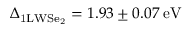<formula> <loc_0><loc_0><loc_500><loc_500>\Delta _ { 1 L W S e _ { 2 } } = 1 . 9 3 \pm 0 . 0 7 \, e V</formula> 